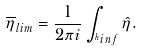<formula> <loc_0><loc_0><loc_500><loc_500>\overline { \eta } _ { l i m } = \frac { 1 } { 2 \pi i } \int _ { ^ { h } i n f } \hat { \eta } .</formula> 